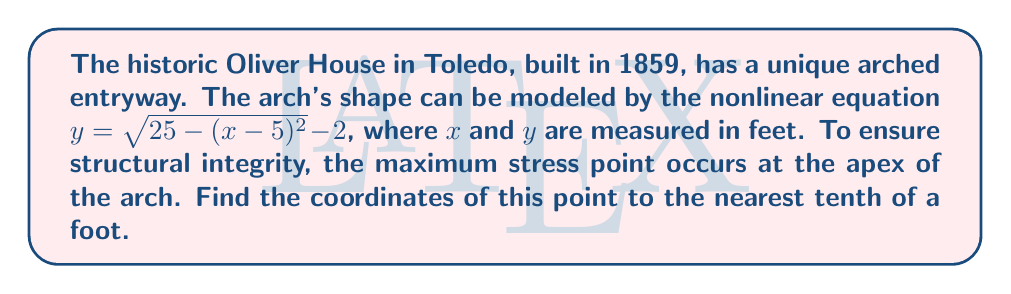Can you solve this math problem? To find the apex of the arch, we need to determine the maximum point of the given equation:

1) The equation of the arch is:
   $y = \sqrt{25 - (x-5)^2} - 2$

2) The apex will occur at the highest point, which is when $x = 5$ (the axis of symmetry of the square root function).

3) Substitute $x = 5$ into the equation:
   $y = \sqrt{25 - (5-5)^2} - 2$
   $y = \sqrt{25 - 0} - 2$
   $y = \sqrt{25} - 2$
   $y = 5 - 2 = 3$

4) Therefore, the coordinates of the apex are (5, 3).

5) Rounding to the nearest tenth (which is already the case here):
   $x = 5.0$ and $y = 3.0$
Answer: (5.0, 3.0) 